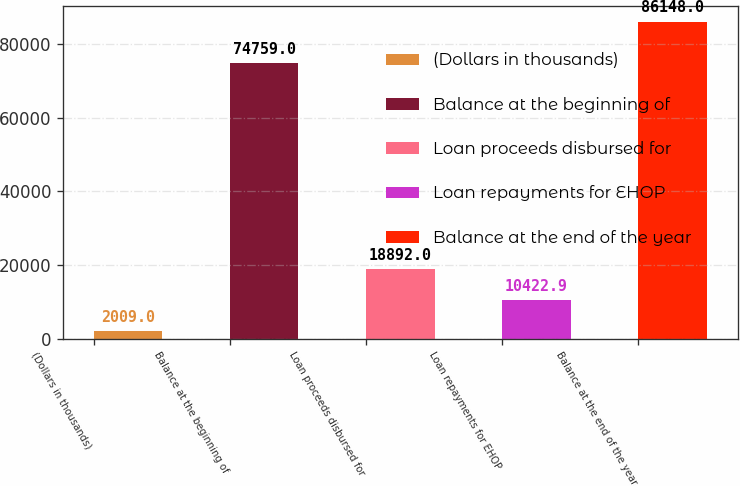<chart> <loc_0><loc_0><loc_500><loc_500><bar_chart><fcel>(Dollars in thousands)<fcel>Balance at the beginning of<fcel>Loan proceeds disbursed for<fcel>Loan repayments for EHOP<fcel>Balance at the end of the year<nl><fcel>2009<fcel>74759<fcel>18892<fcel>10422.9<fcel>86148<nl></chart> 